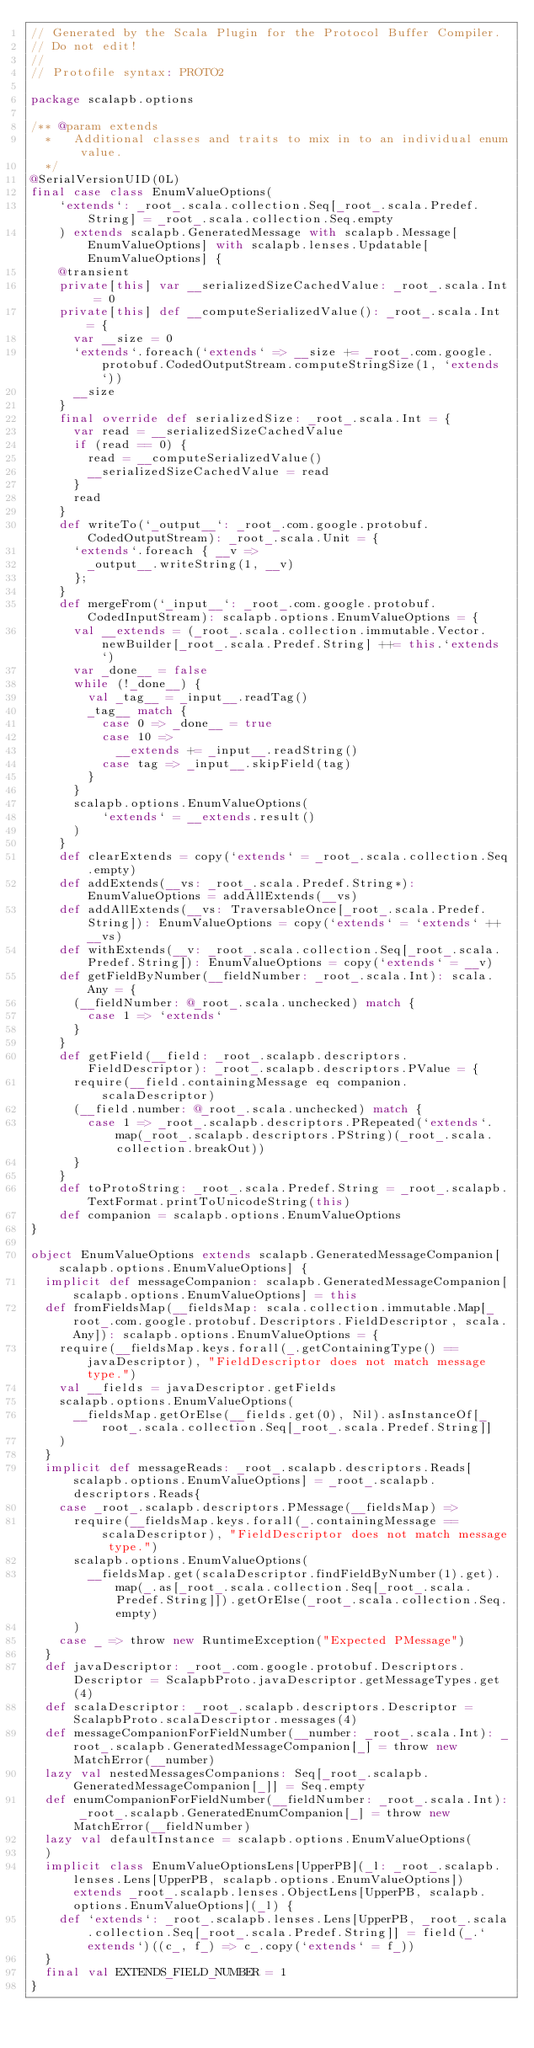Convert code to text. <code><loc_0><loc_0><loc_500><loc_500><_Scala_>// Generated by the Scala Plugin for the Protocol Buffer Compiler.
// Do not edit!
//
// Protofile syntax: PROTO2

package scalapb.options

/** @param extends
  *   Additional classes and traits to mix in to an individual enum value.
  */
@SerialVersionUID(0L)
final case class EnumValueOptions(
    `extends`: _root_.scala.collection.Seq[_root_.scala.Predef.String] = _root_.scala.collection.Seq.empty
    ) extends scalapb.GeneratedMessage with scalapb.Message[EnumValueOptions] with scalapb.lenses.Updatable[EnumValueOptions] {
    @transient
    private[this] var __serializedSizeCachedValue: _root_.scala.Int = 0
    private[this] def __computeSerializedValue(): _root_.scala.Int = {
      var __size = 0
      `extends`.foreach(`extends` => __size += _root_.com.google.protobuf.CodedOutputStream.computeStringSize(1, `extends`))
      __size
    }
    final override def serializedSize: _root_.scala.Int = {
      var read = __serializedSizeCachedValue
      if (read == 0) {
        read = __computeSerializedValue()
        __serializedSizeCachedValue = read
      }
      read
    }
    def writeTo(`_output__`: _root_.com.google.protobuf.CodedOutputStream): _root_.scala.Unit = {
      `extends`.foreach { __v =>
        _output__.writeString(1, __v)
      };
    }
    def mergeFrom(`_input__`: _root_.com.google.protobuf.CodedInputStream): scalapb.options.EnumValueOptions = {
      val __extends = (_root_.scala.collection.immutable.Vector.newBuilder[_root_.scala.Predef.String] ++= this.`extends`)
      var _done__ = false
      while (!_done__) {
        val _tag__ = _input__.readTag()
        _tag__ match {
          case 0 => _done__ = true
          case 10 =>
            __extends += _input__.readString()
          case tag => _input__.skipField(tag)
        }
      }
      scalapb.options.EnumValueOptions(
          `extends` = __extends.result()
      )
    }
    def clearExtends = copy(`extends` = _root_.scala.collection.Seq.empty)
    def addExtends(__vs: _root_.scala.Predef.String*): EnumValueOptions = addAllExtends(__vs)
    def addAllExtends(__vs: TraversableOnce[_root_.scala.Predef.String]): EnumValueOptions = copy(`extends` = `extends` ++ __vs)
    def withExtends(__v: _root_.scala.collection.Seq[_root_.scala.Predef.String]): EnumValueOptions = copy(`extends` = __v)
    def getFieldByNumber(__fieldNumber: _root_.scala.Int): scala.Any = {
      (__fieldNumber: @_root_.scala.unchecked) match {
        case 1 => `extends`
      }
    }
    def getField(__field: _root_.scalapb.descriptors.FieldDescriptor): _root_.scalapb.descriptors.PValue = {
      require(__field.containingMessage eq companion.scalaDescriptor)
      (__field.number: @_root_.scala.unchecked) match {
        case 1 => _root_.scalapb.descriptors.PRepeated(`extends`.map(_root_.scalapb.descriptors.PString)(_root_.scala.collection.breakOut))
      }
    }
    def toProtoString: _root_.scala.Predef.String = _root_.scalapb.TextFormat.printToUnicodeString(this)
    def companion = scalapb.options.EnumValueOptions
}

object EnumValueOptions extends scalapb.GeneratedMessageCompanion[scalapb.options.EnumValueOptions] {
  implicit def messageCompanion: scalapb.GeneratedMessageCompanion[scalapb.options.EnumValueOptions] = this
  def fromFieldsMap(__fieldsMap: scala.collection.immutable.Map[_root_.com.google.protobuf.Descriptors.FieldDescriptor, scala.Any]): scalapb.options.EnumValueOptions = {
    require(__fieldsMap.keys.forall(_.getContainingType() == javaDescriptor), "FieldDescriptor does not match message type.")
    val __fields = javaDescriptor.getFields
    scalapb.options.EnumValueOptions(
      __fieldsMap.getOrElse(__fields.get(0), Nil).asInstanceOf[_root_.scala.collection.Seq[_root_.scala.Predef.String]]
    )
  }
  implicit def messageReads: _root_.scalapb.descriptors.Reads[scalapb.options.EnumValueOptions] = _root_.scalapb.descriptors.Reads{
    case _root_.scalapb.descriptors.PMessage(__fieldsMap) =>
      require(__fieldsMap.keys.forall(_.containingMessage == scalaDescriptor), "FieldDescriptor does not match message type.")
      scalapb.options.EnumValueOptions(
        __fieldsMap.get(scalaDescriptor.findFieldByNumber(1).get).map(_.as[_root_.scala.collection.Seq[_root_.scala.Predef.String]]).getOrElse(_root_.scala.collection.Seq.empty)
      )
    case _ => throw new RuntimeException("Expected PMessage")
  }
  def javaDescriptor: _root_.com.google.protobuf.Descriptors.Descriptor = ScalapbProto.javaDescriptor.getMessageTypes.get(4)
  def scalaDescriptor: _root_.scalapb.descriptors.Descriptor = ScalapbProto.scalaDescriptor.messages(4)
  def messageCompanionForFieldNumber(__number: _root_.scala.Int): _root_.scalapb.GeneratedMessageCompanion[_] = throw new MatchError(__number)
  lazy val nestedMessagesCompanions: Seq[_root_.scalapb.GeneratedMessageCompanion[_]] = Seq.empty
  def enumCompanionForFieldNumber(__fieldNumber: _root_.scala.Int): _root_.scalapb.GeneratedEnumCompanion[_] = throw new MatchError(__fieldNumber)
  lazy val defaultInstance = scalapb.options.EnumValueOptions(
  )
  implicit class EnumValueOptionsLens[UpperPB](_l: _root_.scalapb.lenses.Lens[UpperPB, scalapb.options.EnumValueOptions]) extends _root_.scalapb.lenses.ObjectLens[UpperPB, scalapb.options.EnumValueOptions](_l) {
    def `extends`: _root_.scalapb.lenses.Lens[UpperPB, _root_.scala.collection.Seq[_root_.scala.Predef.String]] = field(_.`extends`)((c_, f_) => c_.copy(`extends` = f_))
  }
  final val EXTENDS_FIELD_NUMBER = 1
}
</code> 